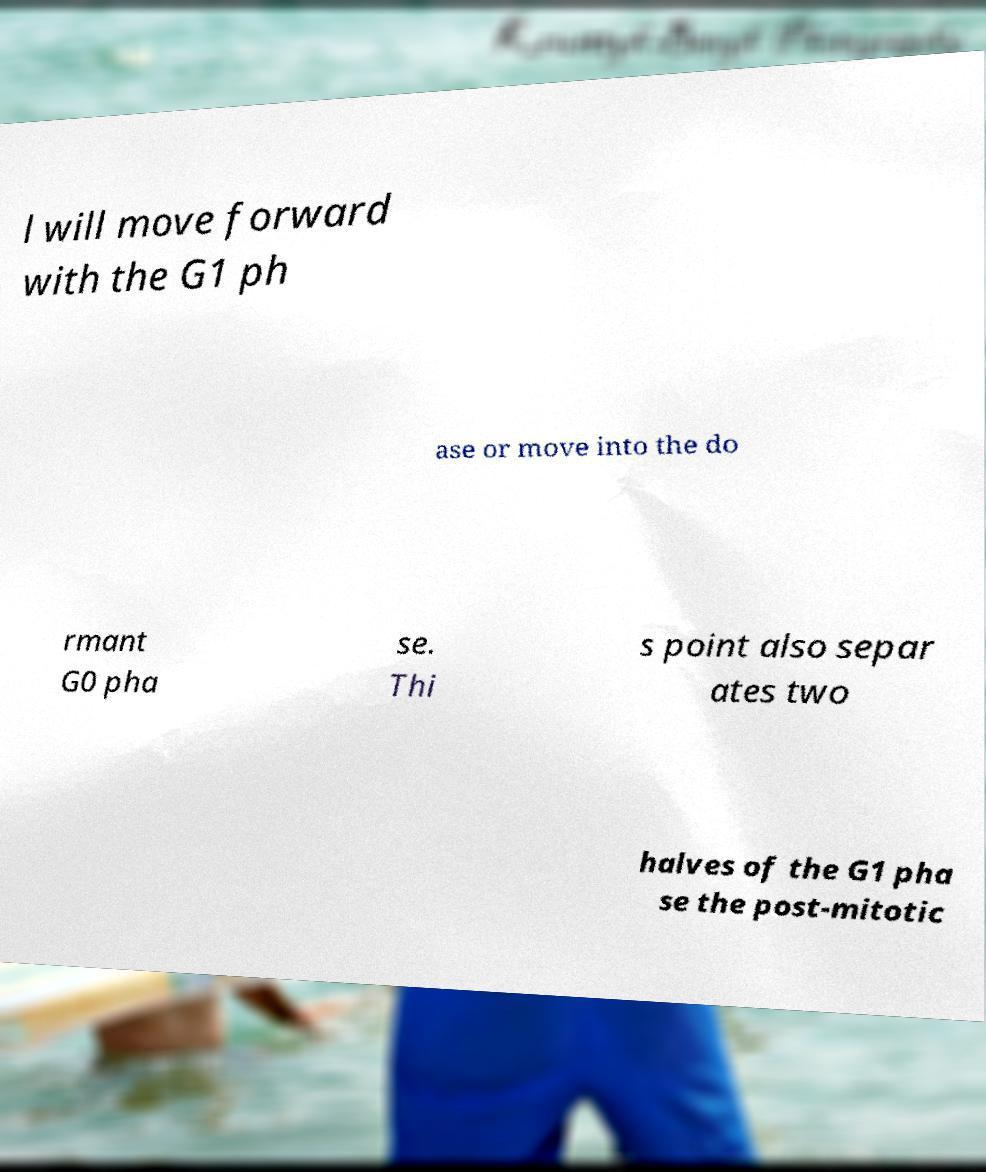Could you assist in decoding the text presented in this image and type it out clearly? l will move forward with the G1 ph ase or move into the do rmant G0 pha se. Thi s point also separ ates two halves of the G1 pha se the post-mitotic 